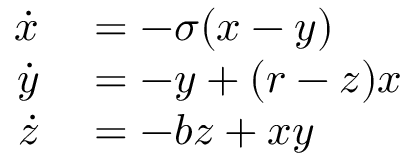<formula> <loc_0><loc_0><loc_500><loc_500>\begin{array} { r l } { \dot { x } } & = - \sigma ( x - y ) } \\ { \dot { y } } & = - y + ( r - z ) x } \\ { \dot { z } } & = - b z + x y } \end{array}</formula> 